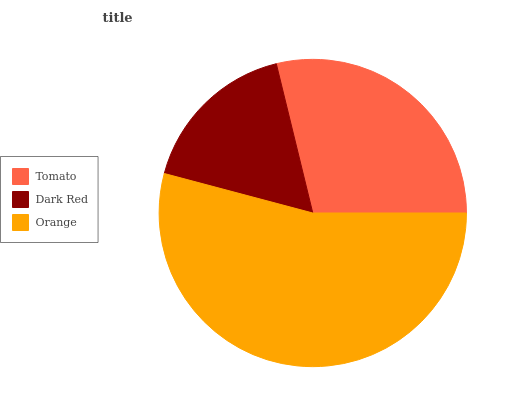Is Dark Red the minimum?
Answer yes or no. Yes. Is Orange the maximum?
Answer yes or no. Yes. Is Orange the minimum?
Answer yes or no. No. Is Dark Red the maximum?
Answer yes or no. No. Is Orange greater than Dark Red?
Answer yes or no. Yes. Is Dark Red less than Orange?
Answer yes or no. Yes. Is Dark Red greater than Orange?
Answer yes or no. No. Is Orange less than Dark Red?
Answer yes or no. No. Is Tomato the high median?
Answer yes or no. Yes. Is Tomato the low median?
Answer yes or no. Yes. Is Dark Red the high median?
Answer yes or no. No. Is Dark Red the low median?
Answer yes or no. No. 